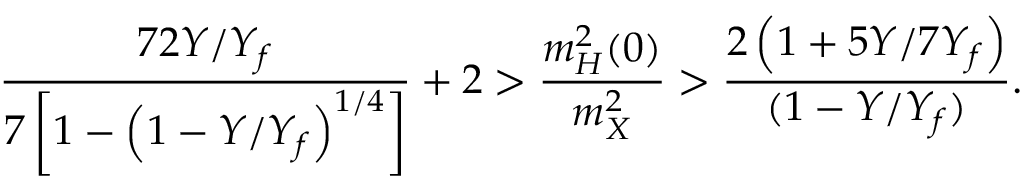<formula> <loc_0><loc_0><loc_500><loc_500>\frac { 7 2 Y / Y _ { f } } { 7 \left [ 1 - \left ( 1 - Y / Y _ { f } \right ) ^ { 1 / 4 } \right ] } + 2 > \frac { m _ { H } ^ { 2 } ( 0 ) } { m _ { X } ^ { 2 } } > \frac { 2 \left ( 1 + 5 Y / 7 Y _ { f } \right ) } { ( 1 - Y / Y _ { f } ) } .</formula> 